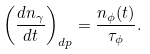Convert formula to latex. <formula><loc_0><loc_0><loc_500><loc_500>\left ( \frac { d n _ { \gamma } } { d t } \right ) _ { d p } = \frac { n _ { \phi } ( t ) } { \tau _ { \phi } } .</formula> 